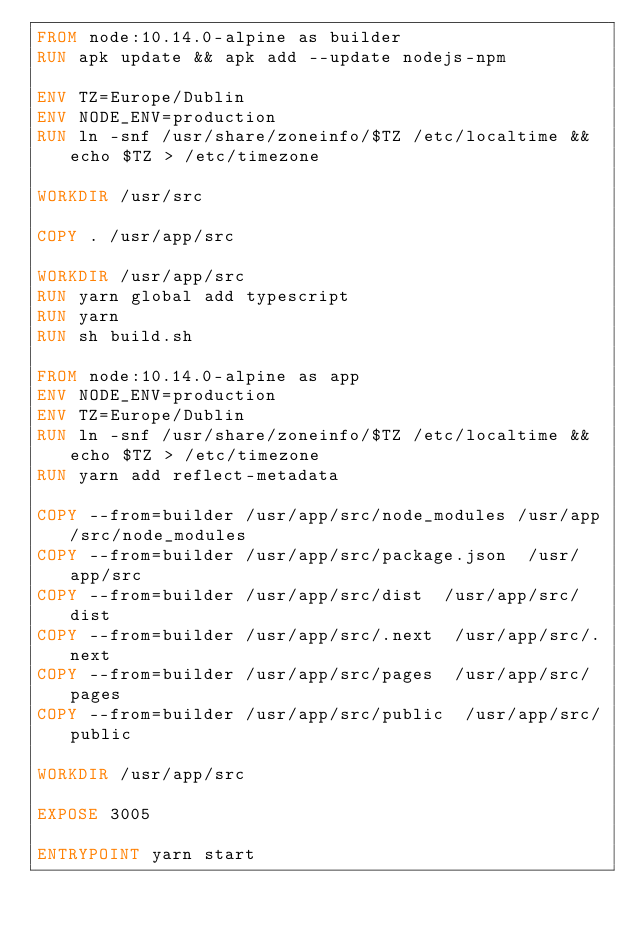<code> <loc_0><loc_0><loc_500><loc_500><_Dockerfile_>FROM node:10.14.0-alpine as builder
RUN apk update && apk add --update nodejs-npm

ENV TZ=Europe/Dublin
ENV NODE_ENV=production
RUN ln -snf /usr/share/zoneinfo/$TZ /etc/localtime && echo $TZ > /etc/timezone

WORKDIR /usr/src

COPY . /usr/app/src

WORKDIR /usr/app/src
RUN yarn global add typescript
RUN yarn
RUN sh build.sh

FROM node:10.14.0-alpine as app
ENV NODE_ENV=production
ENV TZ=Europe/Dublin
RUN ln -snf /usr/share/zoneinfo/$TZ /etc/localtime && echo $TZ > /etc/timezone
RUN yarn add reflect-metadata

COPY --from=builder /usr/app/src/node_modules /usr/app/src/node_modules 
COPY --from=builder /usr/app/src/package.json  /usr/app/src
COPY --from=builder /usr/app/src/dist  /usr/app/src/dist
COPY --from=builder /usr/app/src/.next  /usr/app/src/.next
COPY --from=builder /usr/app/src/pages  /usr/app/src/pages
COPY --from=builder /usr/app/src/public  /usr/app/src/public

WORKDIR /usr/app/src

EXPOSE 3005

ENTRYPOINT yarn start
</code> 